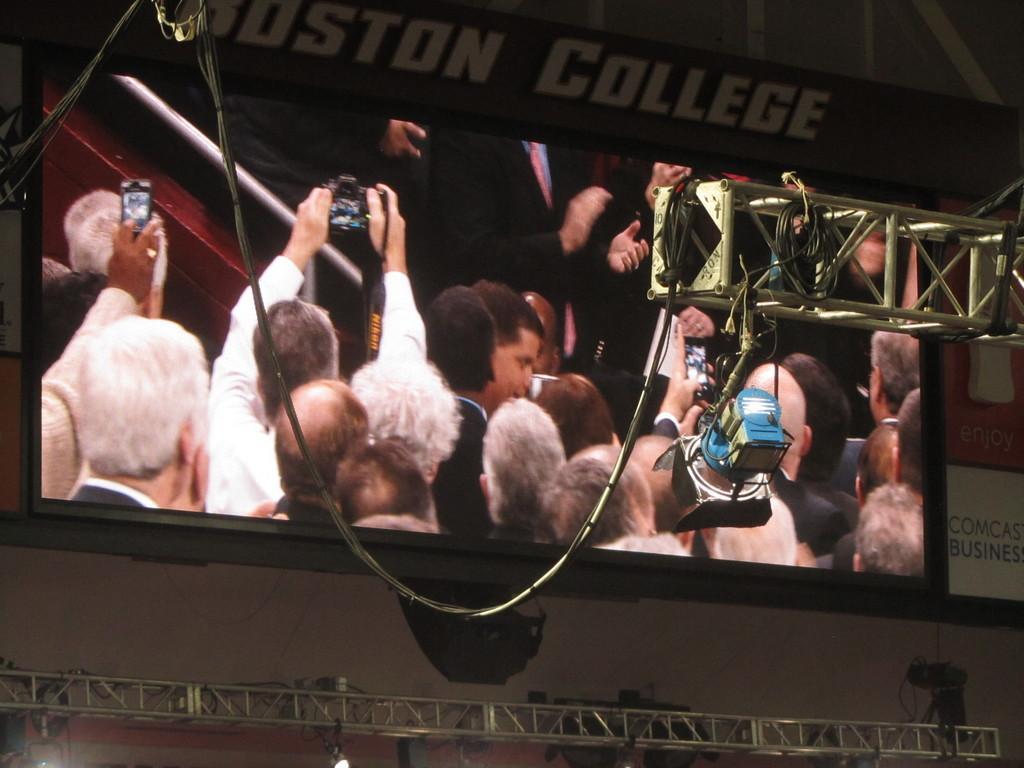In one or two sentences, can you explain what this image depicts? In this picture I can see there is a screen and there are few people holding a smart phone and a camera, in the backdrop there are few people wearing blazers and clapping hands. 